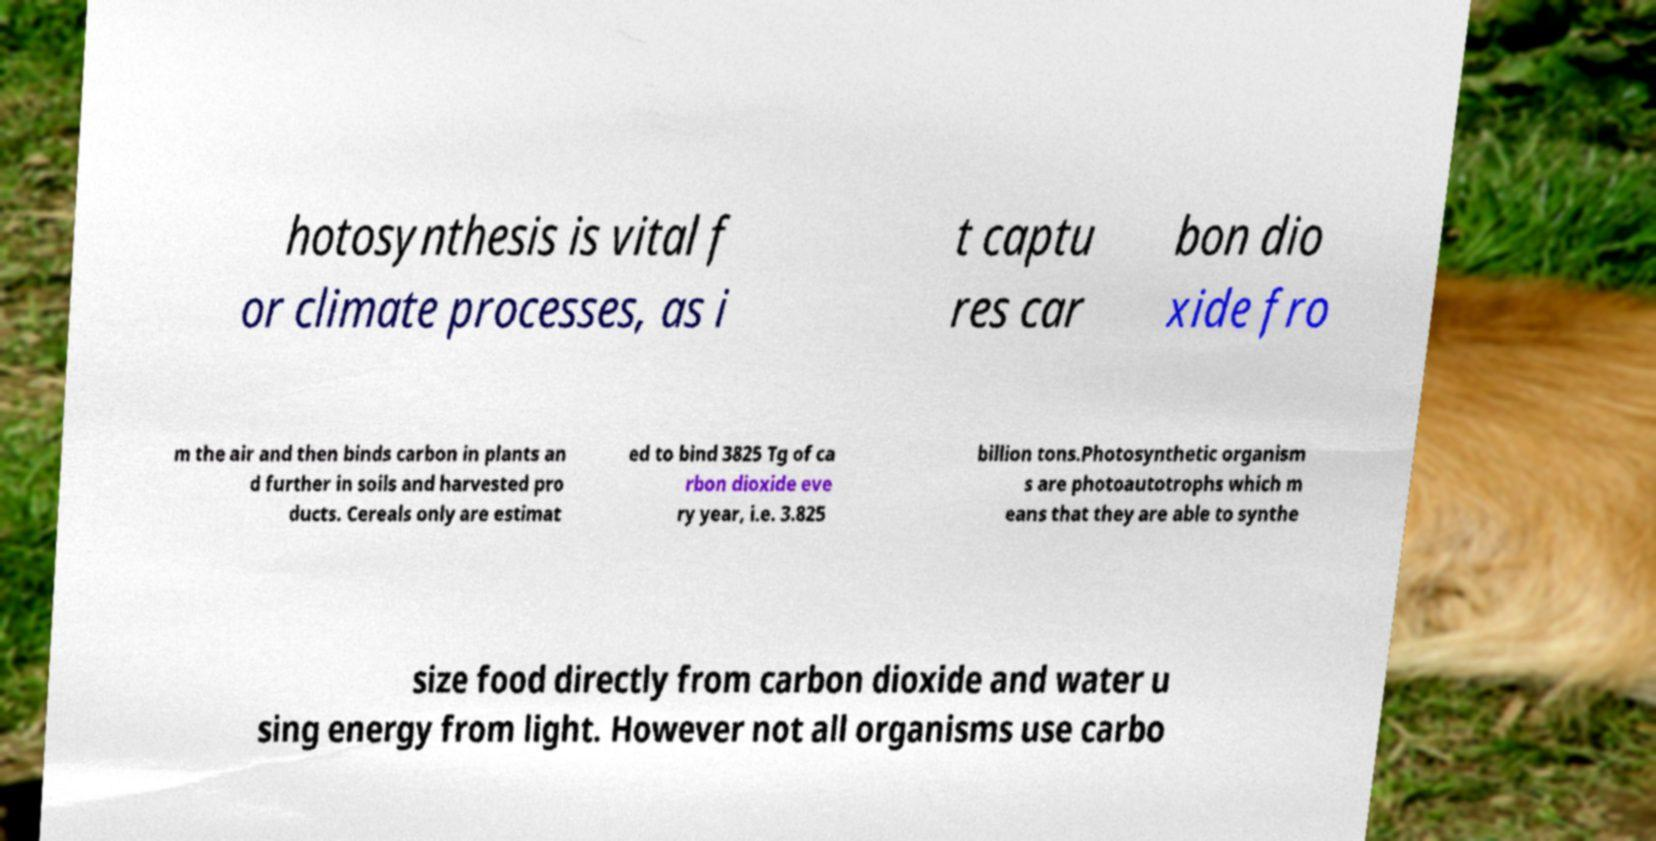Can you accurately transcribe the text from the provided image for me? hotosynthesis is vital f or climate processes, as i t captu res car bon dio xide fro m the air and then binds carbon in plants an d further in soils and harvested pro ducts. Cereals only are estimat ed to bind 3825 Tg of ca rbon dioxide eve ry year, i.e. 3.825 billion tons.Photosynthetic organism s are photoautotrophs which m eans that they are able to synthe size food directly from carbon dioxide and water u sing energy from light. However not all organisms use carbo 